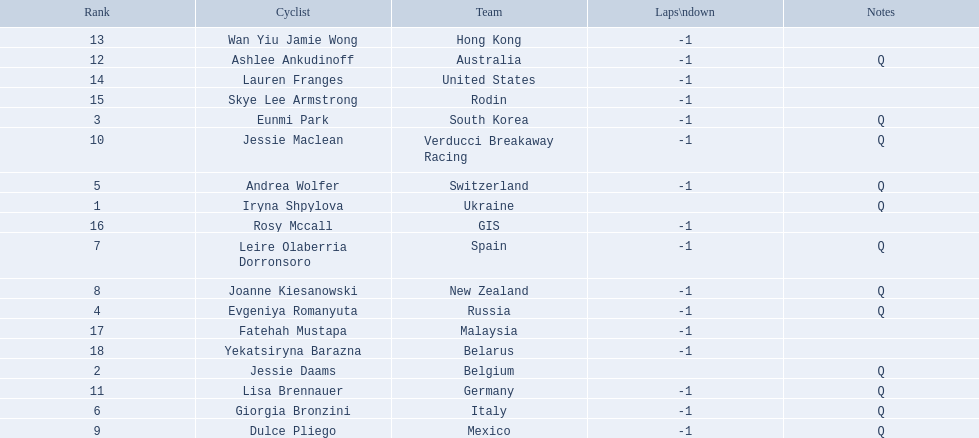Who are all of the cyclists in this race? Iryna Shpylova, Jessie Daams, Eunmi Park, Evgeniya Romanyuta, Andrea Wolfer, Giorgia Bronzini, Leire Olaberria Dorronsoro, Joanne Kiesanowski, Dulce Pliego, Jessie Maclean, Lisa Brennauer, Ashlee Ankudinoff, Wan Yiu Jamie Wong, Lauren Franges, Skye Lee Armstrong, Rosy Mccall, Fatehah Mustapa, Yekatsiryna Barazna. Of these, which one has the lowest numbered rank? Iryna Shpylova. 